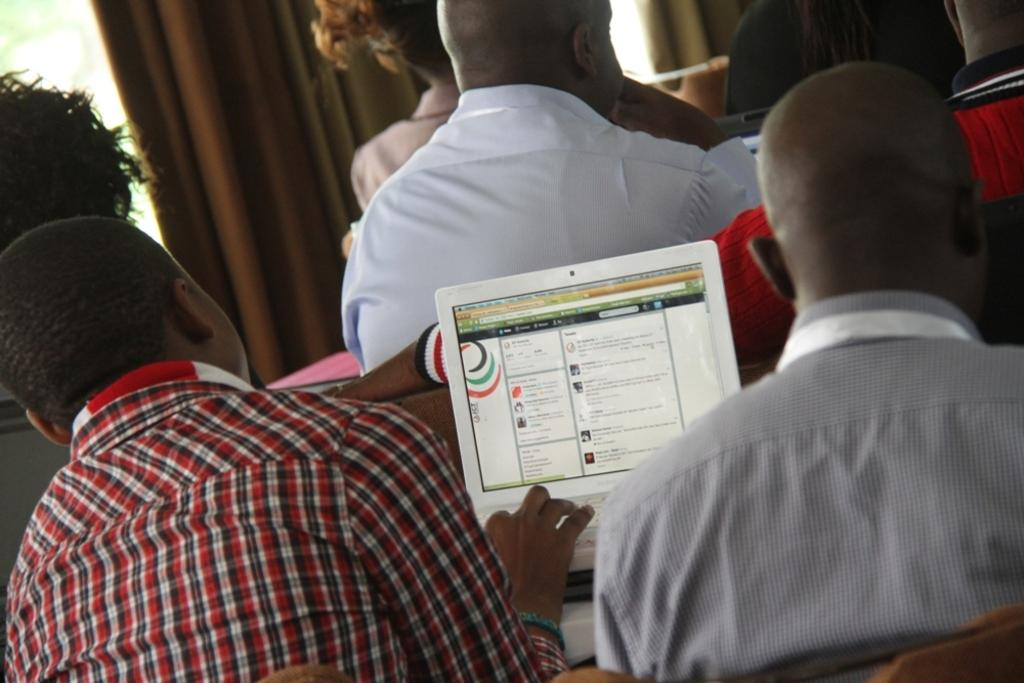What can be seen in the background of the image? There is a curtain in the background of the image. What electronic device is visible in the image? There is a laptop in the image. Are there any people present in the image? Yes, there are people in the image. What type of popcorn is being served to the people in the image? There is no popcorn present in the image. How does the wave affect the laptop in the image? There is no wave present in the image, so it cannot affect the laptop. 